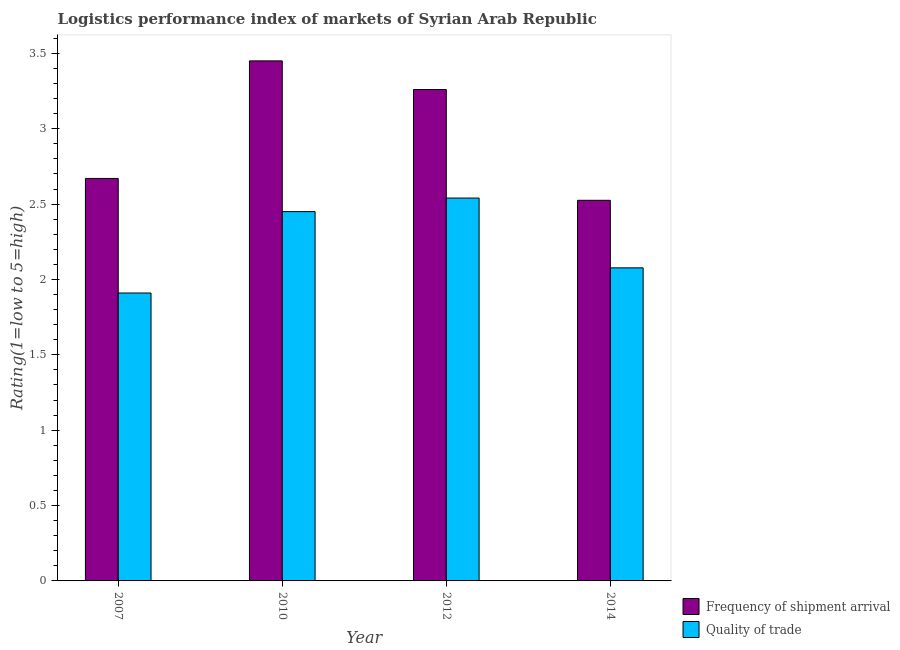How many different coloured bars are there?
Give a very brief answer. 2. How many groups of bars are there?
Offer a very short reply. 4. Are the number of bars on each tick of the X-axis equal?
Offer a terse response. Yes. How many bars are there on the 4th tick from the left?
Keep it short and to the point. 2. What is the label of the 4th group of bars from the left?
Keep it short and to the point. 2014. In how many cases, is the number of bars for a given year not equal to the number of legend labels?
Make the answer very short. 0. What is the lpi of frequency of shipment arrival in 2014?
Offer a terse response. 2.53. Across all years, what is the maximum lpi quality of trade?
Offer a very short reply. 2.54. Across all years, what is the minimum lpi quality of trade?
Offer a very short reply. 1.91. In which year was the lpi quality of trade maximum?
Ensure brevity in your answer.  2012. What is the total lpi of frequency of shipment arrival in the graph?
Offer a terse response. 11.91. What is the difference between the lpi quality of trade in 2007 and that in 2010?
Provide a succinct answer. -0.54. What is the difference between the lpi quality of trade in 2014 and the lpi of frequency of shipment arrival in 2007?
Offer a very short reply. 0.17. What is the average lpi of frequency of shipment arrival per year?
Your answer should be very brief. 2.98. What is the ratio of the lpi quality of trade in 2012 to that in 2014?
Your answer should be very brief. 1.22. Is the lpi of frequency of shipment arrival in 2007 less than that in 2010?
Provide a short and direct response. Yes. What is the difference between the highest and the second highest lpi of frequency of shipment arrival?
Your response must be concise. 0.19. What is the difference between the highest and the lowest lpi quality of trade?
Your answer should be compact. 0.63. In how many years, is the lpi quality of trade greater than the average lpi quality of trade taken over all years?
Your answer should be compact. 2. What does the 2nd bar from the left in 2007 represents?
Offer a very short reply. Quality of trade. What does the 1st bar from the right in 2014 represents?
Provide a short and direct response. Quality of trade. How many years are there in the graph?
Offer a terse response. 4. Are the values on the major ticks of Y-axis written in scientific E-notation?
Provide a short and direct response. No. Does the graph contain any zero values?
Offer a very short reply. No. Does the graph contain grids?
Make the answer very short. No. Where does the legend appear in the graph?
Make the answer very short. Bottom right. How many legend labels are there?
Give a very brief answer. 2. What is the title of the graph?
Your response must be concise. Logistics performance index of markets of Syrian Arab Republic. Does "Electricity and heat production" appear as one of the legend labels in the graph?
Your answer should be very brief. No. What is the label or title of the Y-axis?
Provide a short and direct response. Rating(1=low to 5=high). What is the Rating(1=low to 5=high) in Frequency of shipment arrival in 2007?
Your answer should be compact. 2.67. What is the Rating(1=low to 5=high) of Quality of trade in 2007?
Offer a terse response. 1.91. What is the Rating(1=low to 5=high) in Frequency of shipment arrival in 2010?
Provide a short and direct response. 3.45. What is the Rating(1=low to 5=high) of Quality of trade in 2010?
Offer a very short reply. 2.45. What is the Rating(1=low to 5=high) in Frequency of shipment arrival in 2012?
Give a very brief answer. 3.26. What is the Rating(1=low to 5=high) of Quality of trade in 2012?
Keep it short and to the point. 2.54. What is the Rating(1=low to 5=high) of Frequency of shipment arrival in 2014?
Ensure brevity in your answer.  2.53. What is the Rating(1=low to 5=high) of Quality of trade in 2014?
Ensure brevity in your answer.  2.08. Across all years, what is the maximum Rating(1=low to 5=high) in Frequency of shipment arrival?
Offer a very short reply. 3.45. Across all years, what is the maximum Rating(1=low to 5=high) in Quality of trade?
Provide a succinct answer. 2.54. Across all years, what is the minimum Rating(1=low to 5=high) of Frequency of shipment arrival?
Your answer should be very brief. 2.53. Across all years, what is the minimum Rating(1=low to 5=high) of Quality of trade?
Offer a very short reply. 1.91. What is the total Rating(1=low to 5=high) in Frequency of shipment arrival in the graph?
Give a very brief answer. 11.9. What is the total Rating(1=low to 5=high) of Quality of trade in the graph?
Ensure brevity in your answer.  8.98. What is the difference between the Rating(1=low to 5=high) of Frequency of shipment arrival in 2007 and that in 2010?
Your answer should be very brief. -0.78. What is the difference between the Rating(1=low to 5=high) in Quality of trade in 2007 and that in 2010?
Your response must be concise. -0.54. What is the difference between the Rating(1=low to 5=high) of Frequency of shipment arrival in 2007 and that in 2012?
Your answer should be compact. -0.59. What is the difference between the Rating(1=low to 5=high) of Quality of trade in 2007 and that in 2012?
Your answer should be very brief. -0.63. What is the difference between the Rating(1=low to 5=high) of Frequency of shipment arrival in 2007 and that in 2014?
Your answer should be compact. 0.14. What is the difference between the Rating(1=low to 5=high) in Quality of trade in 2007 and that in 2014?
Ensure brevity in your answer.  -0.17. What is the difference between the Rating(1=low to 5=high) of Frequency of shipment arrival in 2010 and that in 2012?
Your answer should be compact. 0.19. What is the difference between the Rating(1=low to 5=high) of Quality of trade in 2010 and that in 2012?
Your response must be concise. -0.09. What is the difference between the Rating(1=low to 5=high) in Frequency of shipment arrival in 2010 and that in 2014?
Your response must be concise. 0.93. What is the difference between the Rating(1=low to 5=high) in Quality of trade in 2010 and that in 2014?
Provide a succinct answer. 0.37. What is the difference between the Rating(1=low to 5=high) in Frequency of shipment arrival in 2012 and that in 2014?
Provide a short and direct response. 0.73. What is the difference between the Rating(1=low to 5=high) in Quality of trade in 2012 and that in 2014?
Offer a very short reply. 0.46. What is the difference between the Rating(1=low to 5=high) in Frequency of shipment arrival in 2007 and the Rating(1=low to 5=high) in Quality of trade in 2010?
Provide a succinct answer. 0.22. What is the difference between the Rating(1=low to 5=high) of Frequency of shipment arrival in 2007 and the Rating(1=low to 5=high) of Quality of trade in 2012?
Provide a short and direct response. 0.13. What is the difference between the Rating(1=low to 5=high) in Frequency of shipment arrival in 2007 and the Rating(1=low to 5=high) in Quality of trade in 2014?
Offer a terse response. 0.59. What is the difference between the Rating(1=low to 5=high) in Frequency of shipment arrival in 2010 and the Rating(1=low to 5=high) in Quality of trade in 2012?
Your answer should be compact. 0.91. What is the difference between the Rating(1=low to 5=high) in Frequency of shipment arrival in 2010 and the Rating(1=low to 5=high) in Quality of trade in 2014?
Give a very brief answer. 1.37. What is the difference between the Rating(1=low to 5=high) of Frequency of shipment arrival in 2012 and the Rating(1=low to 5=high) of Quality of trade in 2014?
Provide a short and direct response. 1.18. What is the average Rating(1=low to 5=high) of Frequency of shipment arrival per year?
Your response must be concise. 2.98. What is the average Rating(1=low to 5=high) of Quality of trade per year?
Your answer should be very brief. 2.24. In the year 2007, what is the difference between the Rating(1=low to 5=high) in Frequency of shipment arrival and Rating(1=low to 5=high) in Quality of trade?
Keep it short and to the point. 0.76. In the year 2012, what is the difference between the Rating(1=low to 5=high) in Frequency of shipment arrival and Rating(1=low to 5=high) in Quality of trade?
Offer a very short reply. 0.72. In the year 2014, what is the difference between the Rating(1=low to 5=high) of Frequency of shipment arrival and Rating(1=low to 5=high) of Quality of trade?
Keep it short and to the point. 0.45. What is the ratio of the Rating(1=low to 5=high) in Frequency of shipment arrival in 2007 to that in 2010?
Provide a short and direct response. 0.77. What is the ratio of the Rating(1=low to 5=high) in Quality of trade in 2007 to that in 2010?
Offer a terse response. 0.78. What is the ratio of the Rating(1=low to 5=high) of Frequency of shipment arrival in 2007 to that in 2012?
Offer a terse response. 0.82. What is the ratio of the Rating(1=low to 5=high) in Quality of trade in 2007 to that in 2012?
Keep it short and to the point. 0.75. What is the ratio of the Rating(1=low to 5=high) in Frequency of shipment arrival in 2007 to that in 2014?
Your answer should be compact. 1.06. What is the ratio of the Rating(1=low to 5=high) in Quality of trade in 2007 to that in 2014?
Keep it short and to the point. 0.92. What is the ratio of the Rating(1=low to 5=high) in Frequency of shipment arrival in 2010 to that in 2012?
Keep it short and to the point. 1.06. What is the ratio of the Rating(1=low to 5=high) of Quality of trade in 2010 to that in 2012?
Your response must be concise. 0.96. What is the ratio of the Rating(1=low to 5=high) of Frequency of shipment arrival in 2010 to that in 2014?
Make the answer very short. 1.37. What is the ratio of the Rating(1=low to 5=high) in Quality of trade in 2010 to that in 2014?
Offer a terse response. 1.18. What is the ratio of the Rating(1=low to 5=high) in Frequency of shipment arrival in 2012 to that in 2014?
Give a very brief answer. 1.29. What is the ratio of the Rating(1=low to 5=high) in Quality of trade in 2012 to that in 2014?
Your answer should be very brief. 1.22. What is the difference between the highest and the second highest Rating(1=low to 5=high) of Frequency of shipment arrival?
Offer a very short reply. 0.19. What is the difference between the highest and the second highest Rating(1=low to 5=high) in Quality of trade?
Give a very brief answer. 0.09. What is the difference between the highest and the lowest Rating(1=low to 5=high) of Frequency of shipment arrival?
Make the answer very short. 0.93. What is the difference between the highest and the lowest Rating(1=low to 5=high) of Quality of trade?
Provide a short and direct response. 0.63. 